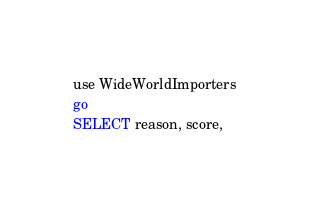Convert code to text. <code><loc_0><loc_0><loc_500><loc_500><_SQL_>use WideWorldImporters
go
SELECT reason, score,</code> 